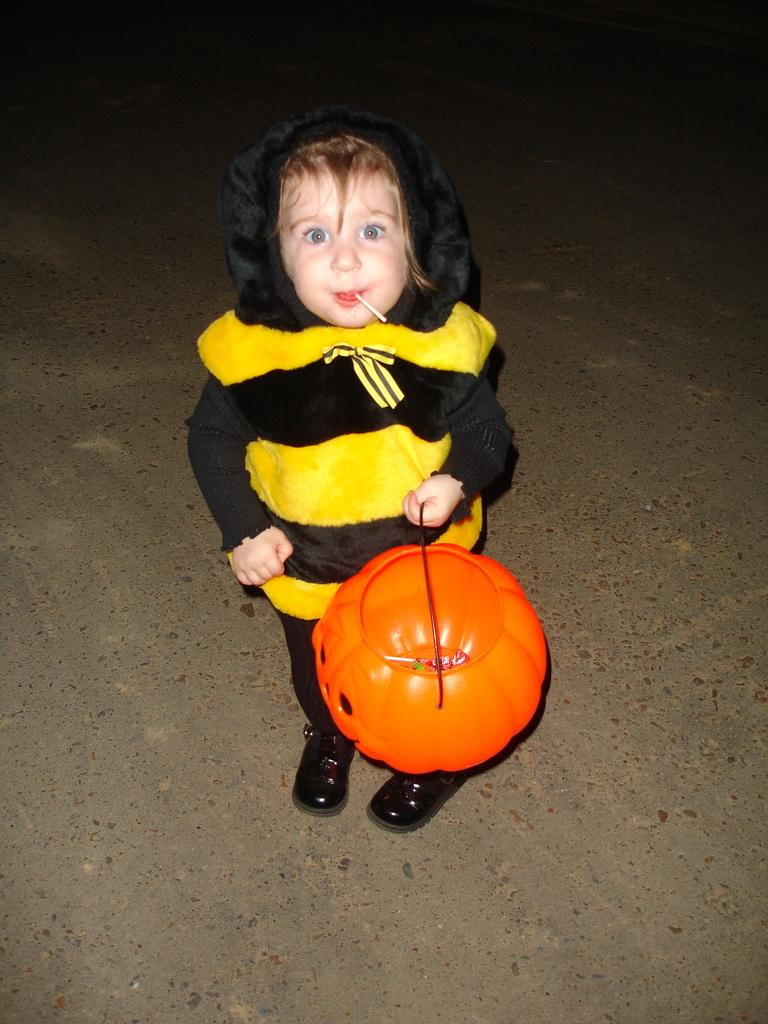What is the main subject in the foreground of the picture? There is a kid in the foreground of the picture. What is the kid holding in her hand? The kid is holding a pumpkin-like object in her hand. What is the kid standing on? The kid is standing on the ground. How many eggs can be seen in the picture? There are no eggs visible in the picture. What type of fish is swimming near the kid in the picture? There is no fish present in the picture. 